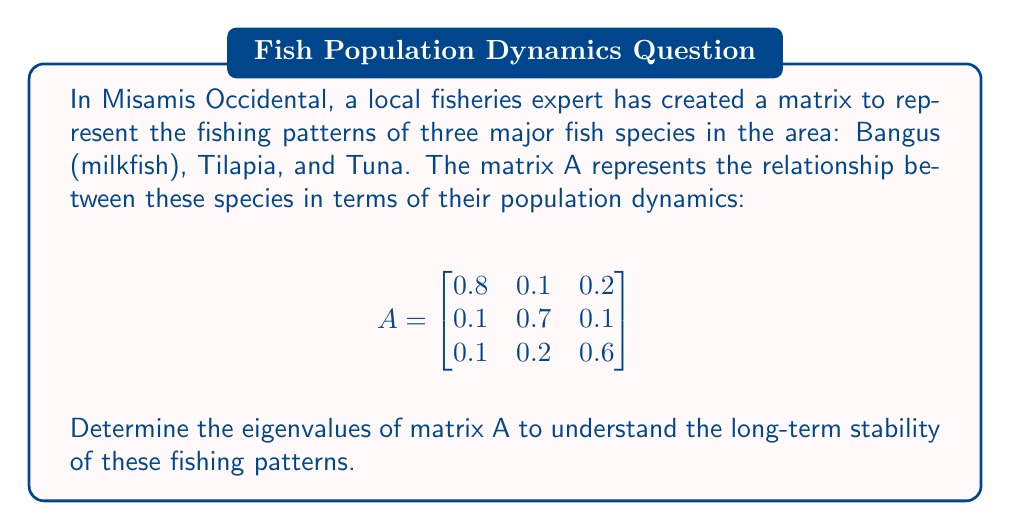Teach me how to tackle this problem. To find the eigenvalues of matrix A, we need to follow these steps:

1) The eigenvalues λ are the solutions to the characteristic equation:
   $det(A - λI) = 0$, where I is the 3x3 identity matrix.

2) Let's expand this:
   $$det\begin{bmatrix}
   0.8-λ & 0.1 & 0.2 \\
   0.1 & 0.7-λ & 0.1 \\
   0.1 & 0.2 & 0.6-λ
   \end{bmatrix} = 0$$

3) Calculating the determinant:
   $(0.8-λ)[(0.7-λ)(0.6-λ) - 0.02] - 0.1[0.1(0.6-λ) - 0.02] + 0.2[0.1(0.7-λ) - 0.01] = 0$

4) Simplifying:
   $(0.8-λ)(0.42-1.3λ+λ^2) - 0.1(0.06-0.1λ) + 0.2(0.07-0.1λ) = 0$

5) Expanding:
   $0.336 - 1.04λ + 0.8λ^2 - 0.42λ + 1.3λ^2 - λ^3 - 0.006 + 0.01λ + 0.014 - 0.02λ = 0$

6) Collecting terms:
   $-λ^3 + 2.1λ^2 - 1.47λ + 0.344 = 0$

7) This is a cubic equation. We can solve it using the cubic formula or numerical methods. The solutions are approximately:

   $λ_1 ≈ 1$
   $λ_2 ≈ 0.7$
   $λ_3 ≈ 0.4$

These are the eigenvalues of matrix A.
Answer: $λ_1 ≈ 1$, $λ_2 ≈ 0.7$, $λ_3 ≈ 0.4$ 